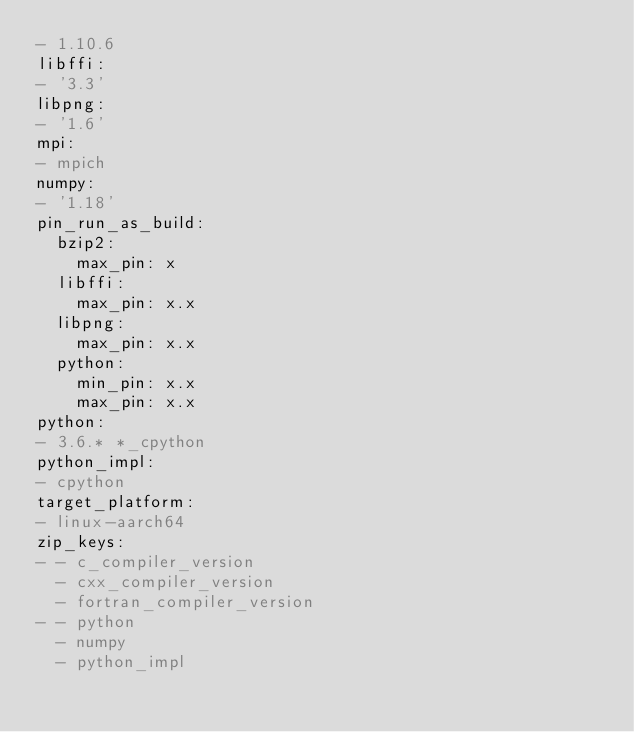<code> <loc_0><loc_0><loc_500><loc_500><_YAML_>- 1.10.6
libffi:
- '3.3'
libpng:
- '1.6'
mpi:
- mpich
numpy:
- '1.18'
pin_run_as_build:
  bzip2:
    max_pin: x
  libffi:
    max_pin: x.x
  libpng:
    max_pin: x.x
  python:
    min_pin: x.x
    max_pin: x.x
python:
- 3.6.* *_cpython
python_impl:
- cpython
target_platform:
- linux-aarch64
zip_keys:
- - c_compiler_version
  - cxx_compiler_version
  - fortran_compiler_version
- - python
  - numpy
  - python_impl
</code> 